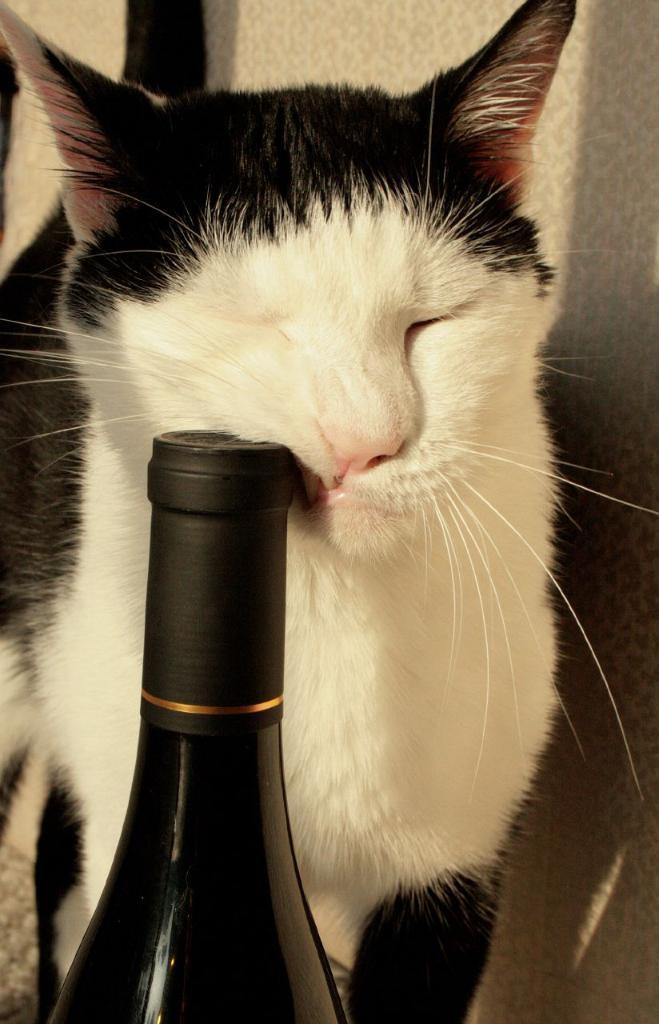How would you summarize this image in a sentence or two? In this image I can see a black and white color cat and I can see at the bottom there a bottle. 